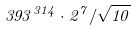<formula> <loc_0><loc_0><loc_500><loc_500>3 9 3 ^ { 3 1 4 } \cdot 2 ^ { 7 } / \sqrt { 1 0 }</formula> 